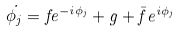Convert formula to latex. <formula><loc_0><loc_0><loc_500><loc_500>\dot { \phi _ { j } } = f e ^ { - i \phi _ { j } } + g + \bar { f } e ^ { i \phi _ { j } }</formula> 